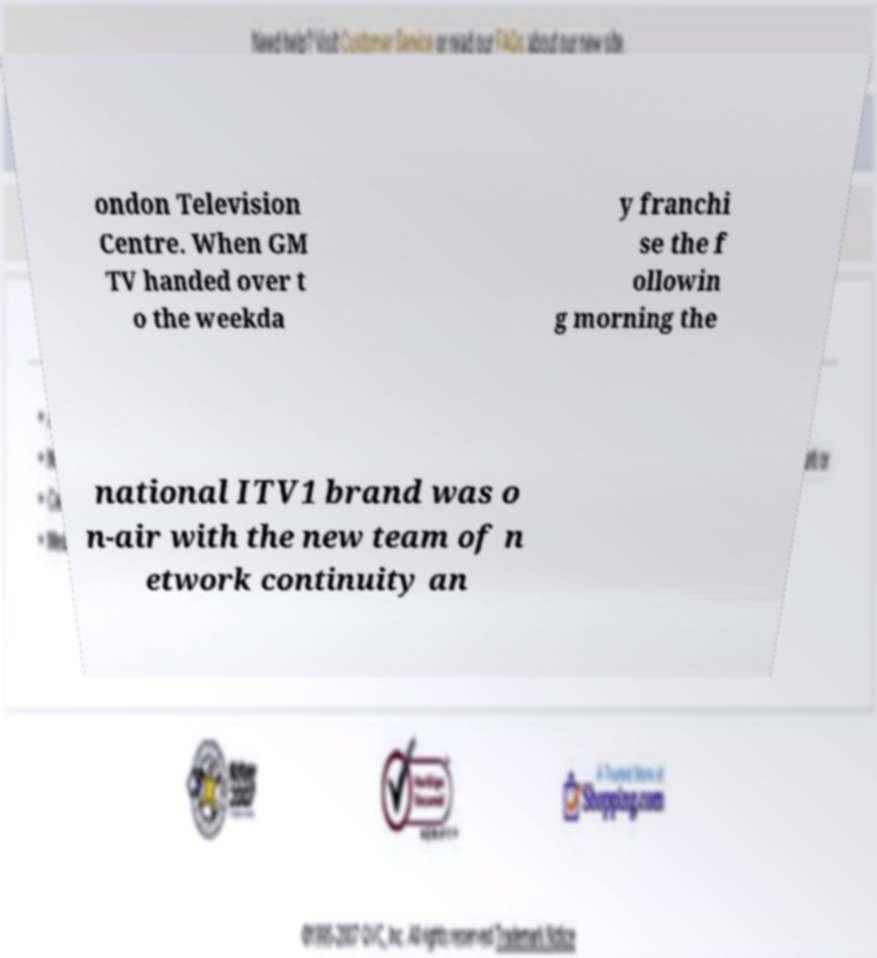I need the written content from this picture converted into text. Can you do that? ondon Television Centre. When GM TV handed over t o the weekda y franchi se the f ollowin g morning the national ITV1 brand was o n-air with the new team of n etwork continuity an 